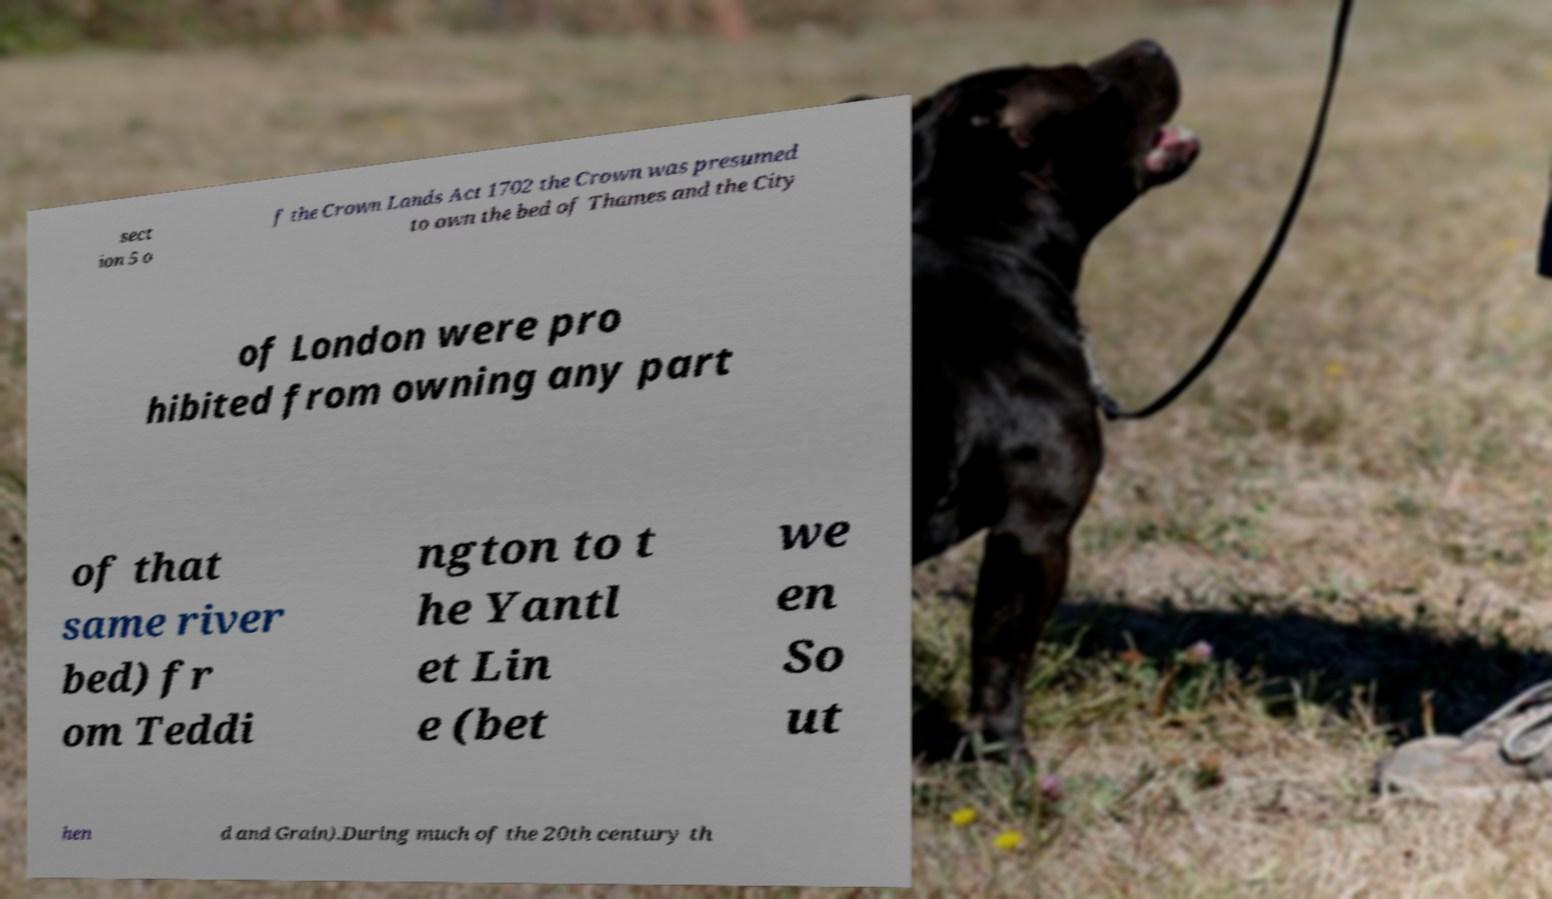Could you extract and type out the text from this image? sect ion 5 o f the Crown Lands Act 1702 the Crown was presumed to own the bed of Thames and the City of London were pro hibited from owning any part of that same river bed) fr om Teddi ngton to t he Yantl et Lin e (bet we en So ut hen d and Grain).During much of the 20th century th 